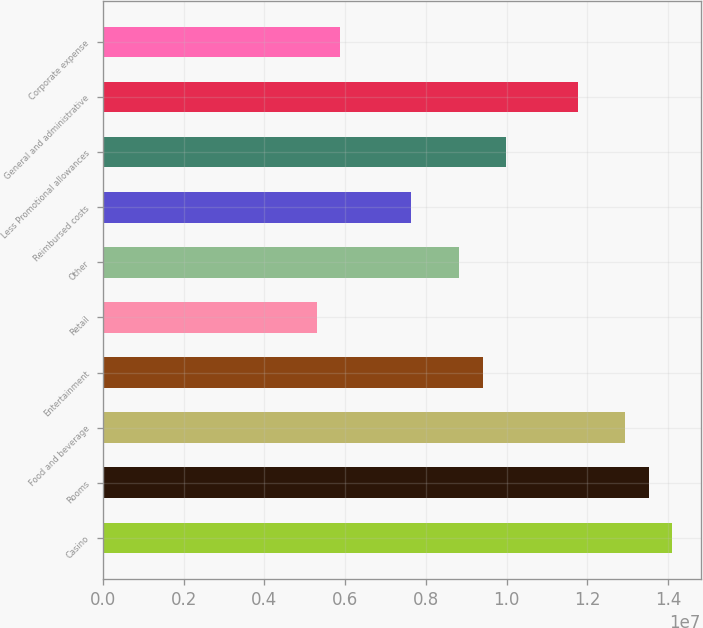Convert chart. <chart><loc_0><loc_0><loc_500><loc_500><bar_chart><fcel>Casino<fcel>Rooms<fcel>Food and beverage<fcel>Entertainment<fcel>Retail<fcel>Other<fcel>Reimbursed costs<fcel>Less Promotional allowances<fcel>General and administrative<fcel>Corporate expense<nl><fcel>1.41091e+07<fcel>1.35212e+07<fcel>1.29333e+07<fcel>9.40604e+06<fcel>5.2909e+06<fcel>8.81816e+06<fcel>7.64241e+06<fcel>9.99392e+06<fcel>1.17575e+07<fcel>5.87878e+06<nl></chart> 